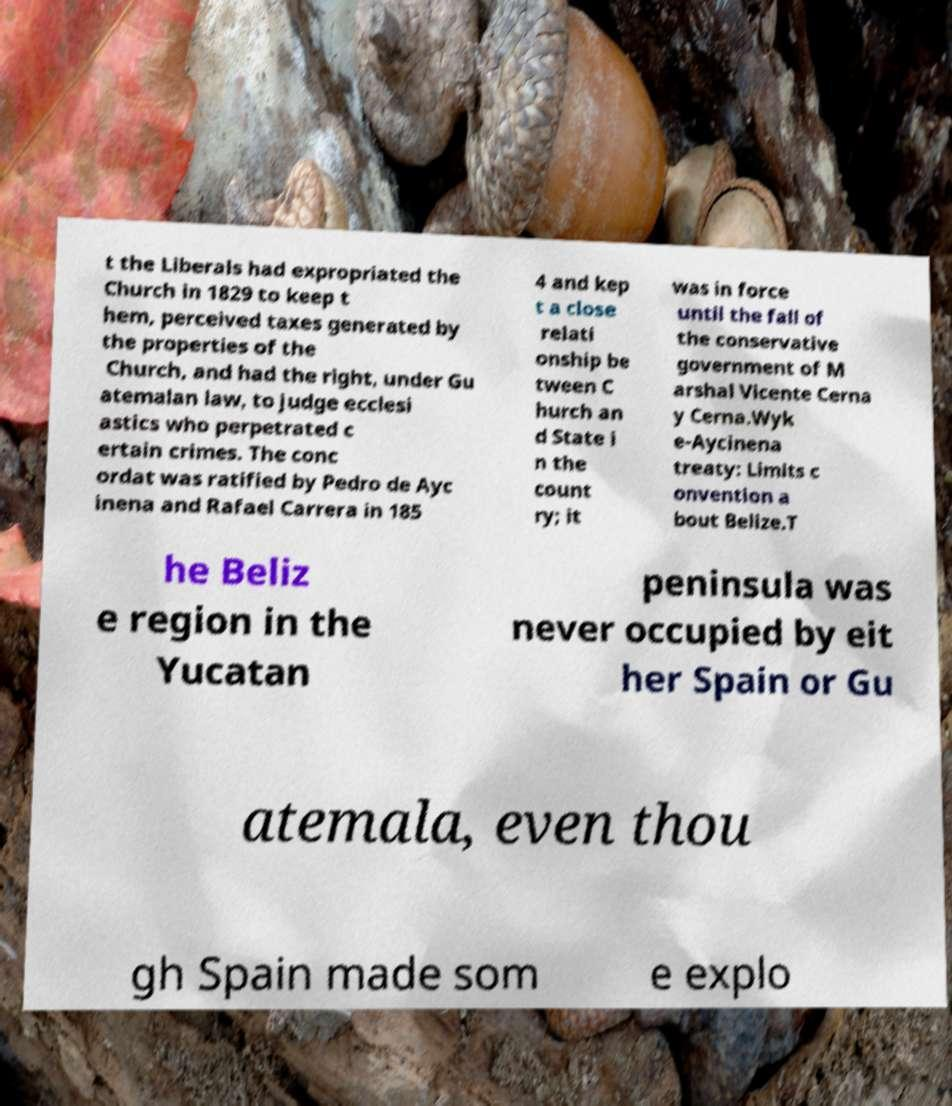Can you accurately transcribe the text from the provided image for me? t the Liberals had expropriated the Church in 1829 to keep t hem, perceived taxes generated by the properties of the Church, and had the right, under Gu atemalan law, to judge ecclesi astics who perpetrated c ertain crimes. The conc ordat was ratified by Pedro de Ayc inena and Rafael Carrera in 185 4 and kep t a close relati onship be tween C hurch an d State i n the count ry; it was in force until the fall of the conservative government of M arshal Vicente Cerna y Cerna.Wyk e-Aycinena treaty: Limits c onvention a bout Belize.T he Beliz e region in the Yucatan peninsula was never occupied by eit her Spain or Gu atemala, even thou gh Spain made som e explo 